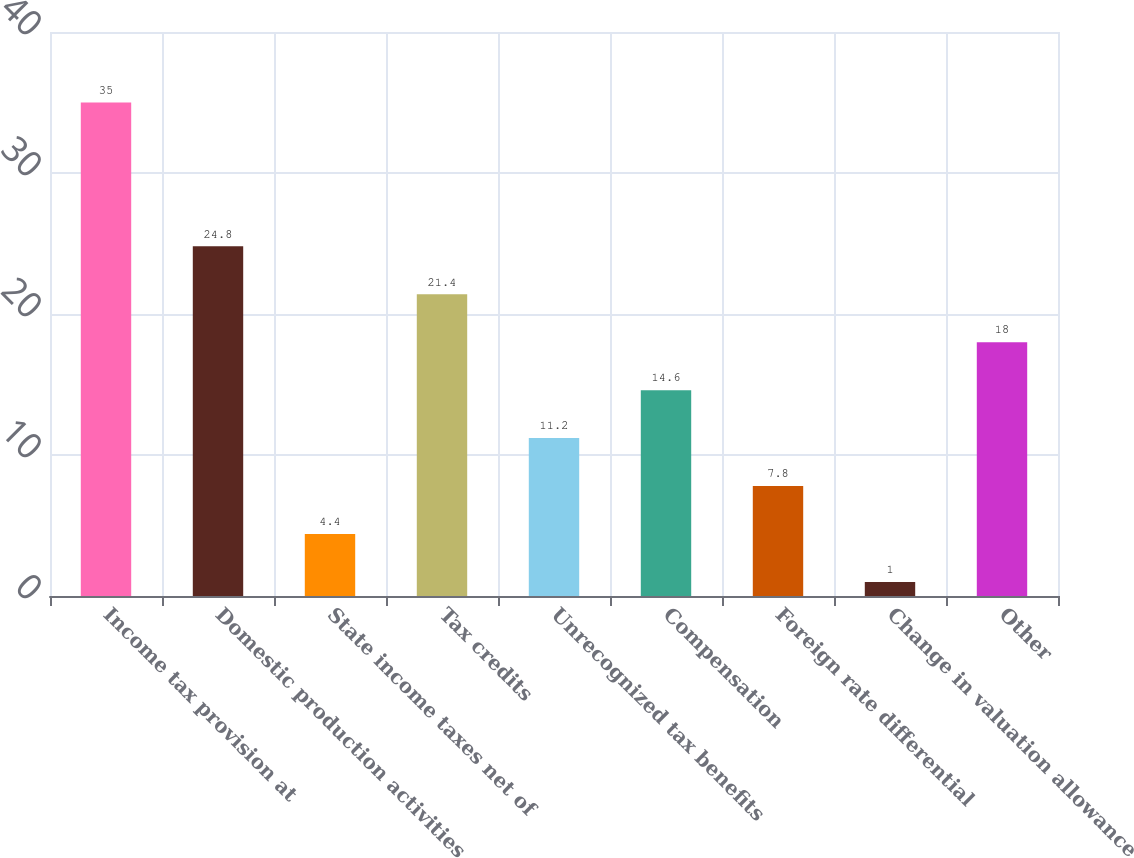<chart> <loc_0><loc_0><loc_500><loc_500><bar_chart><fcel>Income tax provision at<fcel>Domestic production activities<fcel>State income taxes net of<fcel>Tax credits<fcel>Unrecognized tax benefits<fcel>Compensation<fcel>Foreign rate differential<fcel>Change in valuation allowance<fcel>Other<nl><fcel>35<fcel>24.8<fcel>4.4<fcel>21.4<fcel>11.2<fcel>14.6<fcel>7.8<fcel>1<fcel>18<nl></chart> 